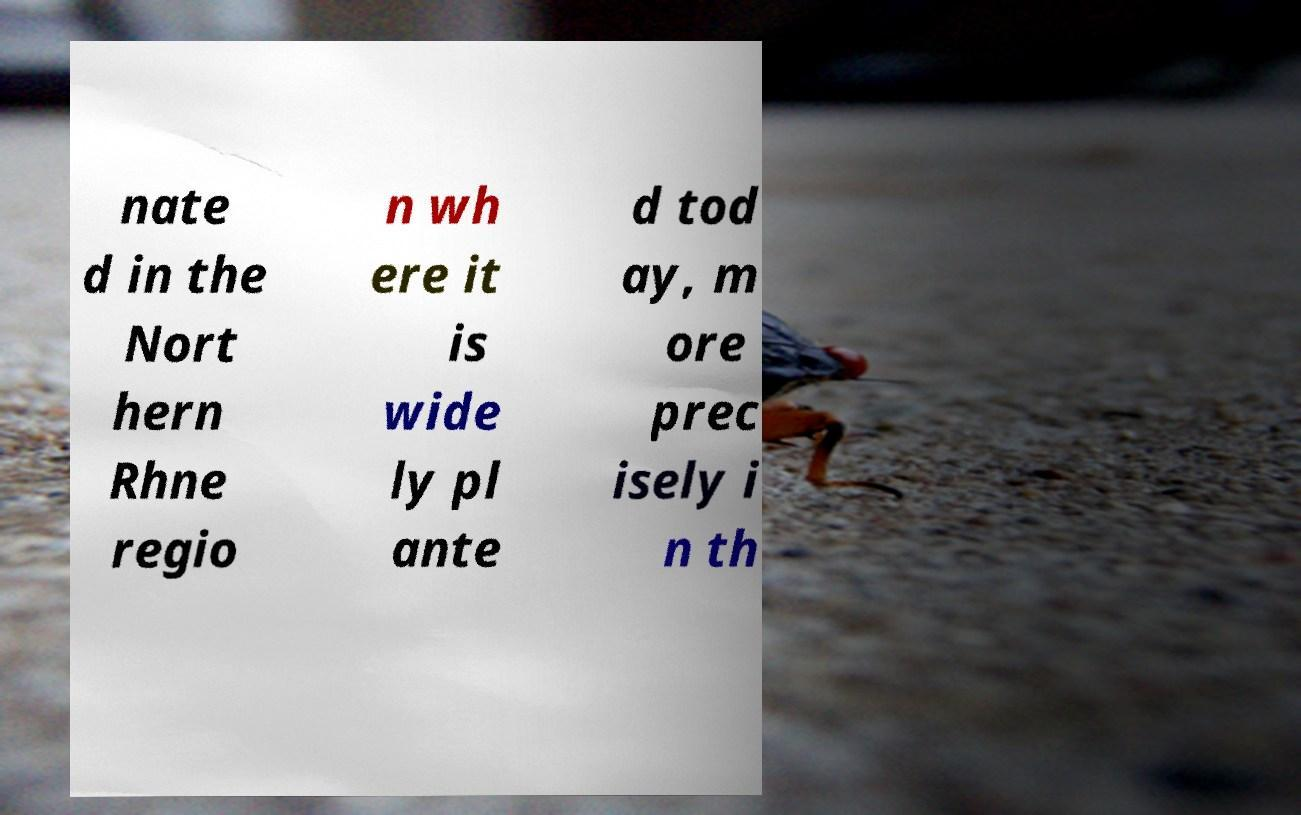Can you accurately transcribe the text from the provided image for me? nate d in the Nort hern Rhne regio n wh ere it is wide ly pl ante d tod ay, m ore prec isely i n th 